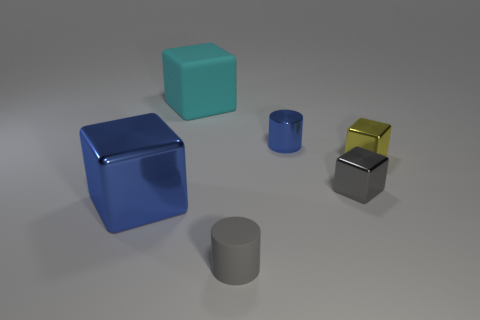Subtract all blue blocks. How many blocks are left? 3 Add 1 cyan objects. How many objects exist? 7 Subtract all blue cylinders. How many cylinders are left? 1 Subtract all cylinders. How many objects are left? 4 Subtract 1 cylinders. How many cylinders are left? 1 Subtract all blue cylinders. Subtract all green balls. How many cylinders are left? 1 Subtract all brown cylinders. How many yellow cubes are left? 1 Subtract all small purple matte blocks. Subtract all small rubber things. How many objects are left? 5 Add 5 gray rubber cylinders. How many gray rubber cylinders are left? 6 Add 1 blue metallic cylinders. How many blue metallic cylinders exist? 2 